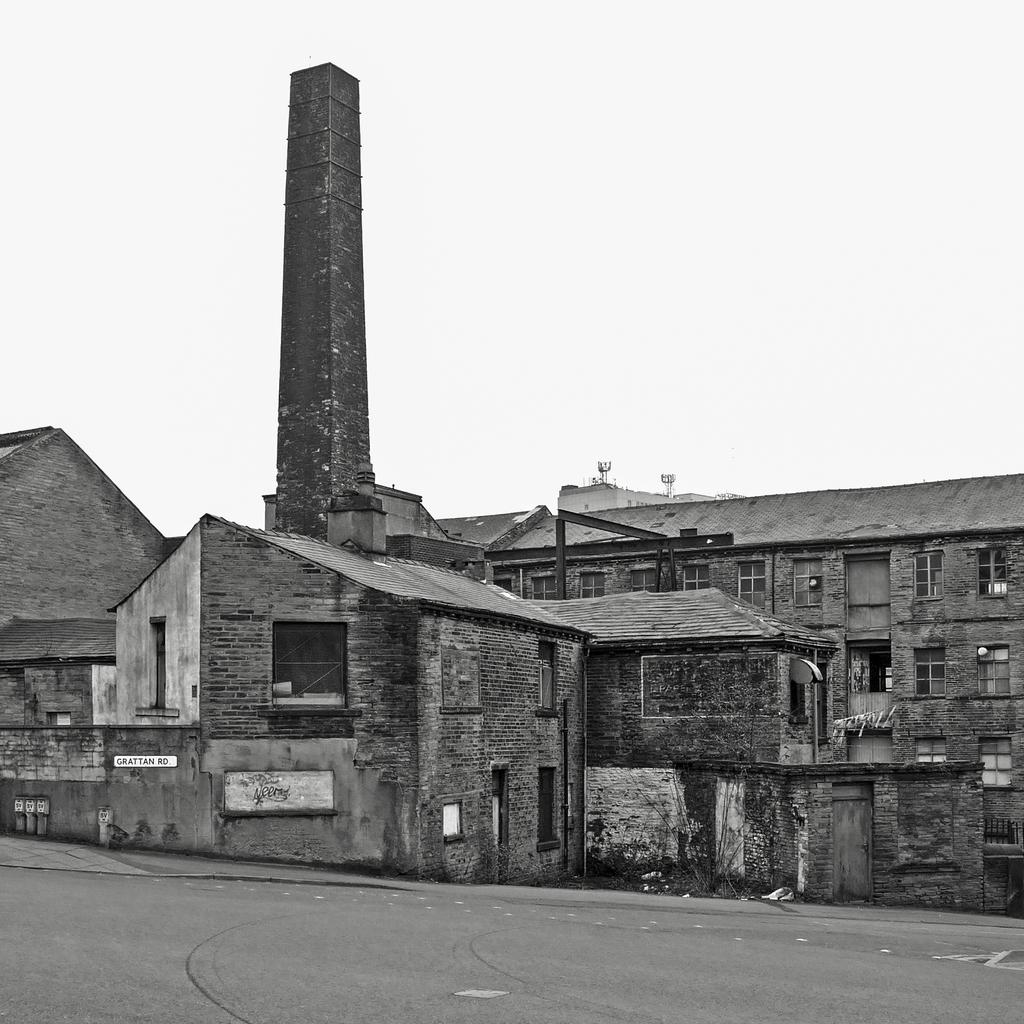What type of structures can be seen in the image? There are buildings in the image. What else is present in the image besides the buildings? There is a road in the image. What part of the natural environment is visible in the image? The sky is visible in the image. How many fairies can be seen flying in the sky in the image? There are no fairies present in the image; only buildings, a road, and the sky are visible. 